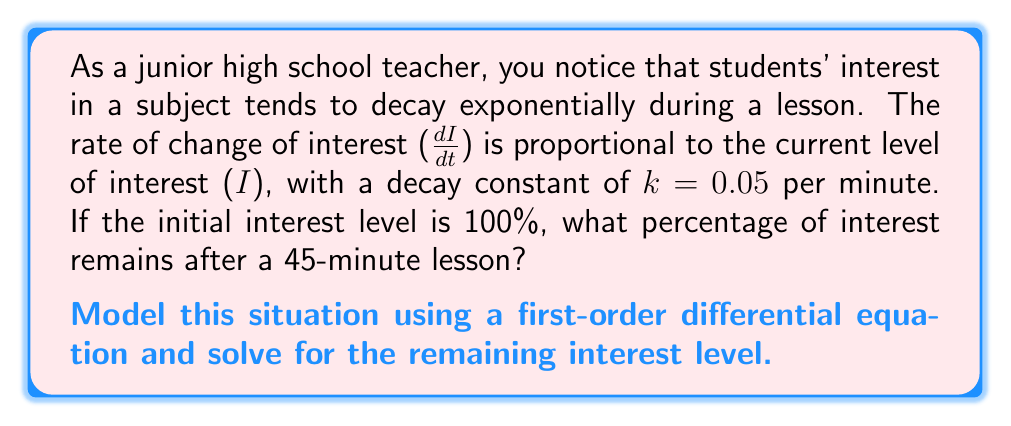Could you help me with this problem? Let's approach this problem step-by-step:

1) First, we need to set up our differential equation. We're told that the rate of change of interest is proportional to the current level of interest:

   $$\frac{dI}{dt} = -kI$$

   The negative sign indicates that interest is decreasing over time.

2) We're given that $k = 0.05$ per minute, so our equation becomes:

   $$\frac{dI}{dt} = -0.05I$$

3) This is a separable first-order differential equation. Let's separate the variables:

   $$\frac{dI}{I} = -0.05dt$$

4) Now we can integrate both sides:

   $$\int \frac{dI}{I} = \int -0.05dt$$

5) This gives us:

   $$\ln|I| = -0.05t + C$$

   Where $C$ is a constant of integration.

6) We can exponentiate both sides to solve for $I$:

   $$I = e^{-0.05t + C} = e^C \cdot e^{-0.05t}$$

7) Let $A = e^C$. This $A$ represents our initial condition. We're told that the initial interest is 100%, or 1 in decimal form. So when $t = 0$, $I = 1$:

   $$1 = A \cdot e^{-0.05 \cdot 0} = A$$

8) Therefore, our solution is:

   $$I(t) = e^{-0.05t}$$

9) To find the interest level after 45 minutes, we plug in $t = 45$:

   $$I(45) = e^{-0.05 \cdot 45} = e^{-2.25} \approx 0.1054$$

10) To convert to a percentage, we multiply by 100:

    $$0.1054 \cdot 100 \approx 10.54\%$$
Answer: After a 45-minute lesson, approximately 10.54% of the initial interest remains. 